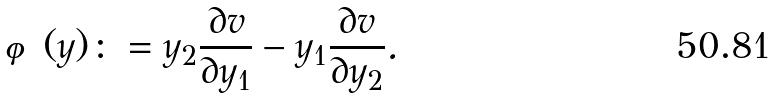Convert formula to latex. <formula><loc_0><loc_0><loc_500><loc_500>\varphi ( y ) \colon = y _ { 2 } \frac { \partial v } { \partial y _ { 1 } } - y _ { 1 } \frac { \partial v } { \partial y _ { 2 } } .</formula> 